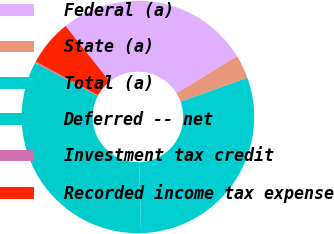<chart> <loc_0><loc_0><loc_500><loc_500><pie_chart><fcel>Federal (a)<fcel>State (a)<fcel>Total (a)<fcel>Deferred -- net<fcel>Investment tax credit<fcel>Recorded income tax expense<nl><fcel>26.93%<fcel>3.29%<fcel>30.04%<fcel>33.14%<fcel>0.19%<fcel>6.4%<nl></chart> 